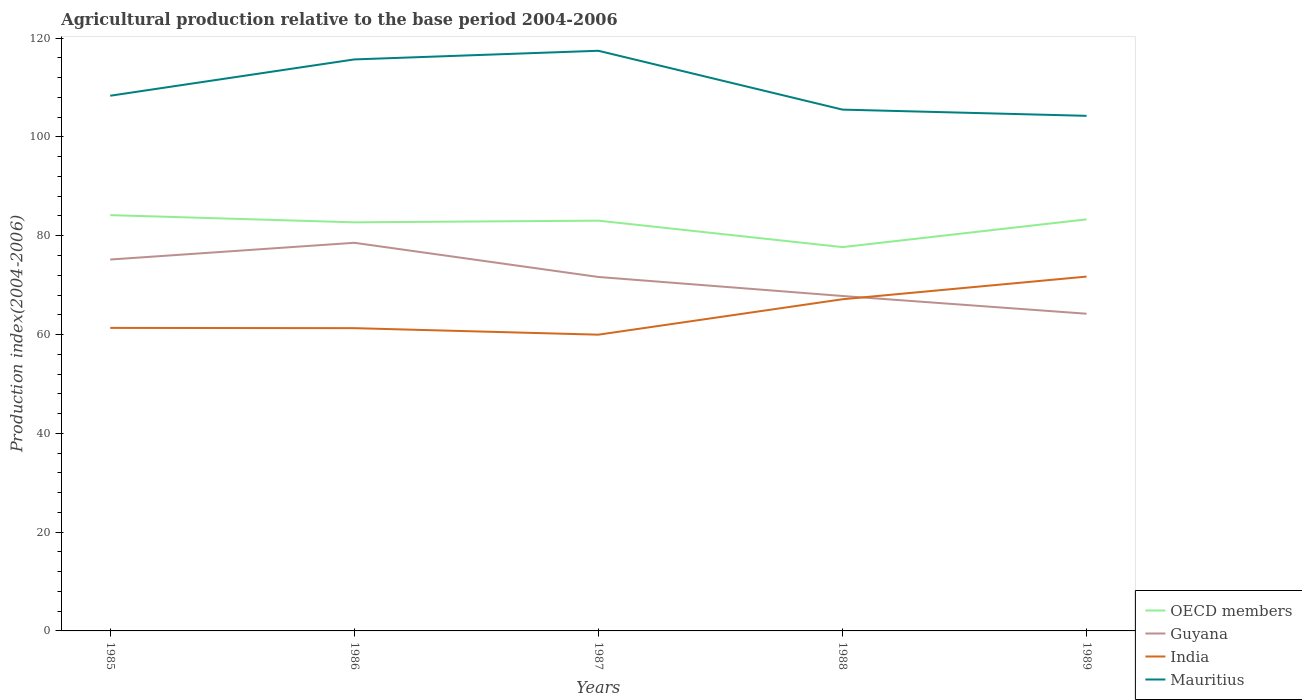How many different coloured lines are there?
Provide a short and direct response. 4. Across all years, what is the maximum agricultural production index in OECD members?
Give a very brief answer. 77.7. What is the total agricultural production index in Mauritius in the graph?
Make the answer very short. 2.81. What is the difference between the highest and the second highest agricultural production index in India?
Provide a succinct answer. 11.76. Are the values on the major ticks of Y-axis written in scientific E-notation?
Offer a terse response. No. Does the graph contain any zero values?
Offer a very short reply. No. Where does the legend appear in the graph?
Offer a terse response. Bottom right. What is the title of the graph?
Provide a short and direct response. Agricultural production relative to the base period 2004-2006. Does "Netherlands" appear as one of the legend labels in the graph?
Provide a short and direct response. No. What is the label or title of the Y-axis?
Provide a succinct answer. Production index(2004-2006). What is the Production index(2004-2006) of OECD members in 1985?
Your response must be concise. 84.17. What is the Production index(2004-2006) in Guyana in 1985?
Make the answer very short. 75.18. What is the Production index(2004-2006) of India in 1985?
Your response must be concise. 61.34. What is the Production index(2004-2006) in Mauritius in 1985?
Keep it short and to the point. 108.34. What is the Production index(2004-2006) in OECD members in 1986?
Give a very brief answer. 82.71. What is the Production index(2004-2006) in Guyana in 1986?
Keep it short and to the point. 78.57. What is the Production index(2004-2006) of India in 1986?
Offer a terse response. 61.29. What is the Production index(2004-2006) in Mauritius in 1986?
Offer a very short reply. 115.69. What is the Production index(2004-2006) in OECD members in 1987?
Your response must be concise. 83.05. What is the Production index(2004-2006) of Guyana in 1987?
Your response must be concise. 71.65. What is the Production index(2004-2006) of India in 1987?
Offer a very short reply. 59.97. What is the Production index(2004-2006) in Mauritius in 1987?
Provide a short and direct response. 117.44. What is the Production index(2004-2006) of OECD members in 1988?
Your answer should be compact. 77.7. What is the Production index(2004-2006) in Guyana in 1988?
Your answer should be compact. 67.8. What is the Production index(2004-2006) in India in 1988?
Make the answer very short. 67.14. What is the Production index(2004-2006) of Mauritius in 1988?
Ensure brevity in your answer.  105.53. What is the Production index(2004-2006) of OECD members in 1989?
Your answer should be compact. 83.31. What is the Production index(2004-2006) of Guyana in 1989?
Ensure brevity in your answer.  64.21. What is the Production index(2004-2006) in India in 1989?
Provide a succinct answer. 71.73. What is the Production index(2004-2006) of Mauritius in 1989?
Offer a terse response. 104.27. Across all years, what is the maximum Production index(2004-2006) of OECD members?
Keep it short and to the point. 84.17. Across all years, what is the maximum Production index(2004-2006) of Guyana?
Provide a short and direct response. 78.57. Across all years, what is the maximum Production index(2004-2006) in India?
Keep it short and to the point. 71.73. Across all years, what is the maximum Production index(2004-2006) in Mauritius?
Your answer should be compact. 117.44. Across all years, what is the minimum Production index(2004-2006) in OECD members?
Make the answer very short. 77.7. Across all years, what is the minimum Production index(2004-2006) of Guyana?
Offer a very short reply. 64.21. Across all years, what is the minimum Production index(2004-2006) of India?
Your response must be concise. 59.97. Across all years, what is the minimum Production index(2004-2006) in Mauritius?
Provide a short and direct response. 104.27. What is the total Production index(2004-2006) in OECD members in the graph?
Keep it short and to the point. 410.94. What is the total Production index(2004-2006) of Guyana in the graph?
Make the answer very short. 357.41. What is the total Production index(2004-2006) of India in the graph?
Give a very brief answer. 321.47. What is the total Production index(2004-2006) in Mauritius in the graph?
Ensure brevity in your answer.  551.27. What is the difference between the Production index(2004-2006) of OECD members in 1985 and that in 1986?
Your response must be concise. 1.46. What is the difference between the Production index(2004-2006) in Guyana in 1985 and that in 1986?
Your answer should be very brief. -3.39. What is the difference between the Production index(2004-2006) of Mauritius in 1985 and that in 1986?
Your response must be concise. -7.35. What is the difference between the Production index(2004-2006) of OECD members in 1985 and that in 1987?
Provide a succinct answer. 1.12. What is the difference between the Production index(2004-2006) of Guyana in 1985 and that in 1987?
Your answer should be compact. 3.53. What is the difference between the Production index(2004-2006) of India in 1985 and that in 1987?
Provide a succinct answer. 1.37. What is the difference between the Production index(2004-2006) in OECD members in 1985 and that in 1988?
Your response must be concise. 6.47. What is the difference between the Production index(2004-2006) of Guyana in 1985 and that in 1988?
Your response must be concise. 7.38. What is the difference between the Production index(2004-2006) of India in 1985 and that in 1988?
Your response must be concise. -5.8. What is the difference between the Production index(2004-2006) of Mauritius in 1985 and that in 1988?
Ensure brevity in your answer.  2.81. What is the difference between the Production index(2004-2006) of OECD members in 1985 and that in 1989?
Make the answer very short. 0.86. What is the difference between the Production index(2004-2006) of Guyana in 1985 and that in 1989?
Your response must be concise. 10.97. What is the difference between the Production index(2004-2006) in India in 1985 and that in 1989?
Provide a succinct answer. -10.39. What is the difference between the Production index(2004-2006) in Mauritius in 1985 and that in 1989?
Your answer should be very brief. 4.07. What is the difference between the Production index(2004-2006) in OECD members in 1986 and that in 1987?
Your answer should be very brief. -0.34. What is the difference between the Production index(2004-2006) of Guyana in 1986 and that in 1987?
Ensure brevity in your answer.  6.92. What is the difference between the Production index(2004-2006) in India in 1986 and that in 1987?
Your answer should be compact. 1.32. What is the difference between the Production index(2004-2006) of Mauritius in 1986 and that in 1987?
Keep it short and to the point. -1.75. What is the difference between the Production index(2004-2006) in OECD members in 1986 and that in 1988?
Ensure brevity in your answer.  5.01. What is the difference between the Production index(2004-2006) in Guyana in 1986 and that in 1988?
Give a very brief answer. 10.77. What is the difference between the Production index(2004-2006) of India in 1986 and that in 1988?
Your answer should be very brief. -5.85. What is the difference between the Production index(2004-2006) of Mauritius in 1986 and that in 1988?
Ensure brevity in your answer.  10.16. What is the difference between the Production index(2004-2006) of OECD members in 1986 and that in 1989?
Your answer should be compact. -0.6. What is the difference between the Production index(2004-2006) of Guyana in 1986 and that in 1989?
Ensure brevity in your answer.  14.36. What is the difference between the Production index(2004-2006) in India in 1986 and that in 1989?
Provide a short and direct response. -10.44. What is the difference between the Production index(2004-2006) in Mauritius in 1986 and that in 1989?
Offer a very short reply. 11.42. What is the difference between the Production index(2004-2006) of OECD members in 1987 and that in 1988?
Make the answer very short. 5.36. What is the difference between the Production index(2004-2006) of Guyana in 1987 and that in 1988?
Provide a short and direct response. 3.85. What is the difference between the Production index(2004-2006) of India in 1987 and that in 1988?
Keep it short and to the point. -7.17. What is the difference between the Production index(2004-2006) of Mauritius in 1987 and that in 1988?
Provide a succinct answer. 11.91. What is the difference between the Production index(2004-2006) in OECD members in 1987 and that in 1989?
Your response must be concise. -0.26. What is the difference between the Production index(2004-2006) of Guyana in 1987 and that in 1989?
Offer a very short reply. 7.44. What is the difference between the Production index(2004-2006) of India in 1987 and that in 1989?
Give a very brief answer. -11.76. What is the difference between the Production index(2004-2006) in Mauritius in 1987 and that in 1989?
Provide a short and direct response. 13.17. What is the difference between the Production index(2004-2006) in OECD members in 1988 and that in 1989?
Ensure brevity in your answer.  -5.62. What is the difference between the Production index(2004-2006) in Guyana in 1988 and that in 1989?
Make the answer very short. 3.59. What is the difference between the Production index(2004-2006) of India in 1988 and that in 1989?
Offer a terse response. -4.59. What is the difference between the Production index(2004-2006) in Mauritius in 1988 and that in 1989?
Offer a very short reply. 1.26. What is the difference between the Production index(2004-2006) in OECD members in 1985 and the Production index(2004-2006) in Guyana in 1986?
Offer a terse response. 5.6. What is the difference between the Production index(2004-2006) of OECD members in 1985 and the Production index(2004-2006) of India in 1986?
Keep it short and to the point. 22.88. What is the difference between the Production index(2004-2006) in OECD members in 1985 and the Production index(2004-2006) in Mauritius in 1986?
Provide a short and direct response. -31.52. What is the difference between the Production index(2004-2006) of Guyana in 1985 and the Production index(2004-2006) of India in 1986?
Provide a short and direct response. 13.89. What is the difference between the Production index(2004-2006) in Guyana in 1985 and the Production index(2004-2006) in Mauritius in 1986?
Your answer should be very brief. -40.51. What is the difference between the Production index(2004-2006) in India in 1985 and the Production index(2004-2006) in Mauritius in 1986?
Ensure brevity in your answer.  -54.35. What is the difference between the Production index(2004-2006) of OECD members in 1985 and the Production index(2004-2006) of Guyana in 1987?
Your answer should be very brief. 12.52. What is the difference between the Production index(2004-2006) of OECD members in 1985 and the Production index(2004-2006) of India in 1987?
Offer a terse response. 24.2. What is the difference between the Production index(2004-2006) in OECD members in 1985 and the Production index(2004-2006) in Mauritius in 1987?
Offer a terse response. -33.27. What is the difference between the Production index(2004-2006) of Guyana in 1985 and the Production index(2004-2006) of India in 1987?
Offer a terse response. 15.21. What is the difference between the Production index(2004-2006) of Guyana in 1985 and the Production index(2004-2006) of Mauritius in 1987?
Your response must be concise. -42.26. What is the difference between the Production index(2004-2006) in India in 1985 and the Production index(2004-2006) in Mauritius in 1987?
Offer a terse response. -56.1. What is the difference between the Production index(2004-2006) of OECD members in 1985 and the Production index(2004-2006) of Guyana in 1988?
Offer a very short reply. 16.37. What is the difference between the Production index(2004-2006) in OECD members in 1985 and the Production index(2004-2006) in India in 1988?
Your answer should be compact. 17.03. What is the difference between the Production index(2004-2006) in OECD members in 1985 and the Production index(2004-2006) in Mauritius in 1988?
Provide a succinct answer. -21.36. What is the difference between the Production index(2004-2006) of Guyana in 1985 and the Production index(2004-2006) of India in 1988?
Provide a short and direct response. 8.04. What is the difference between the Production index(2004-2006) of Guyana in 1985 and the Production index(2004-2006) of Mauritius in 1988?
Your response must be concise. -30.35. What is the difference between the Production index(2004-2006) of India in 1985 and the Production index(2004-2006) of Mauritius in 1988?
Your response must be concise. -44.19. What is the difference between the Production index(2004-2006) in OECD members in 1985 and the Production index(2004-2006) in Guyana in 1989?
Your answer should be compact. 19.96. What is the difference between the Production index(2004-2006) in OECD members in 1985 and the Production index(2004-2006) in India in 1989?
Give a very brief answer. 12.44. What is the difference between the Production index(2004-2006) of OECD members in 1985 and the Production index(2004-2006) of Mauritius in 1989?
Your answer should be very brief. -20.1. What is the difference between the Production index(2004-2006) of Guyana in 1985 and the Production index(2004-2006) of India in 1989?
Provide a short and direct response. 3.45. What is the difference between the Production index(2004-2006) in Guyana in 1985 and the Production index(2004-2006) in Mauritius in 1989?
Give a very brief answer. -29.09. What is the difference between the Production index(2004-2006) in India in 1985 and the Production index(2004-2006) in Mauritius in 1989?
Keep it short and to the point. -42.93. What is the difference between the Production index(2004-2006) in OECD members in 1986 and the Production index(2004-2006) in Guyana in 1987?
Make the answer very short. 11.06. What is the difference between the Production index(2004-2006) of OECD members in 1986 and the Production index(2004-2006) of India in 1987?
Provide a short and direct response. 22.74. What is the difference between the Production index(2004-2006) of OECD members in 1986 and the Production index(2004-2006) of Mauritius in 1987?
Your answer should be very brief. -34.73. What is the difference between the Production index(2004-2006) in Guyana in 1986 and the Production index(2004-2006) in Mauritius in 1987?
Provide a succinct answer. -38.87. What is the difference between the Production index(2004-2006) in India in 1986 and the Production index(2004-2006) in Mauritius in 1987?
Provide a short and direct response. -56.15. What is the difference between the Production index(2004-2006) of OECD members in 1986 and the Production index(2004-2006) of Guyana in 1988?
Offer a terse response. 14.91. What is the difference between the Production index(2004-2006) in OECD members in 1986 and the Production index(2004-2006) in India in 1988?
Ensure brevity in your answer.  15.57. What is the difference between the Production index(2004-2006) in OECD members in 1986 and the Production index(2004-2006) in Mauritius in 1988?
Offer a terse response. -22.82. What is the difference between the Production index(2004-2006) of Guyana in 1986 and the Production index(2004-2006) of India in 1988?
Your response must be concise. 11.43. What is the difference between the Production index(2004-2006) of Guyana in 1986 and the Production index(2004-2006) of Mauritius in 1988?
Ensure brevity in your answer.  -26.96. What is the difference between the Production index(2004-2006) in India in 1986 and the Production index(2004-2006) in Mauritius in 1988?
Give a very brief answer. -44.24. What is the difference between the Production index(2004-2006) of OECD members in 1986 and the Production index(2004-2006) of Guyana in 1989?
Make the answer very short. 18.5. What is the difference between the Production index(2004-2006) of OECD members in 1986 and the Production index(2004-2006) of India in 1989?
Provide a succinct answer. 10.98. What is the difference between the Production index(2004-2006) of OECD members in 1986 and the Production index(2004-2006) of Mauritius in 1989?
Provide a short and direct response. -21.56. What is the difference between the Production index(2004-2006) in Guyana in 1986 and the Production index(2004-2006) in India in 1989?
Your response must be concise. 6.84. What is the difference between the Production index(2004-2006) of Guyana in 1986 and the Production index(2004-2006) of Mauritius in 1989?
Your response must be concise. -25.7. What is the difference between the Production index(2004-2006) of India in 1986 and the Production index(2004-2006) of Mauritius in 1989?
Ensure brevity in your answer.  -42.98. What is the difference between the Production index(2004-2006) in OECD members in 1987 and the Production index(2004-2006) in Guyana in 1988?
Offer a terse response. 15.25. What is the difference between the Production index(2004-2006) in OECD members in 1987 and the Production index(2004-2006) in India in 1988?
Your answer should be compact. 15.91. What is the difference between the Production index(2004-2006) of OECD members in 1987 and the Production index(2004-2006) of Mauritius in 1988?
Provide a short and direct response. -22.48. What is the difference between the Production index(2004-2006) in Guyana in 1987 and the Production index(2004-2006) in India in 1988?
Your response must be concise. 4.51. What is the difference between the Production index(2004-2006) of Guyana in 1987 and the Production index(2004-2006) of Mauritius in 1988?
Offer a very short reply. -33.88. What is the difference between the Production index(2004-2006) in India in 1987 and the Production index(2004-2006) in Mauritius in 1988?
Make the answer very short. -45.56. What is the difference between the Production index(2004-2006) of OECD members in 1987 and the Production index(2004-2006) of Guyana in 1989?
Provide a succinct answer. 18.84. What is the difference between the Production index(2004-2006) in OECD members in 1987 and the Production index(2004-2006) in India in 1989?
Your answer should be compact. 11.32. What is the difference between the Production index(2004-2006) in OECD members in 1987 and the Production index(2004-2006) in Mauritius in 1989?
Your response must be concise. -21.22. What is the difference between the Production index(2004-2006) of Guyana in 1987 and the Production index(2004-2006) of India in 1989?
Provide a short and direct response. -0.08. What is the difference between the Production index(2004-2006) in Guyana in 1987 and the Production index(2004-2006) in Mauritius in 1989?
Your response must be concise. -32.62. What is the difference between the Production index(2004-2006) in India in 1987 and the Production index(2004-2006) in Mauritius in 1989?
Provide a succinct answer. -44.3. What is the difference between the Production index(2004-2006) in OECD members in 1988 and the Production index(2004-2006) in Guyana in 1989?
Offer a terse response. 13.49. What is the difference between the Production index(2004-2006) of OECD members in 1988 and the Production index(2004-2006) of India in 1989?
Offer a very short reply. 5.97. What is the difference between the Production index(2004-2006) of OECD members in 1988 and the Production index(2004-2006) of Mauritius in 1989?
Give a very brief answer. -26.57. What is the difference between the Production index(2004-2006) of Guyana in 1988 and the Production index(2004-2006) of India in 1989?
Provide a succinct answer. -3.93. What is the difference between the Production index(2004-2006) of Guyana in 1988 and the Production index(2004-2006) of Mauritius in 1989?
Ensure brevity in your answer.  -36.47. What is the difference between the Production index(2004-2006) of India in 1988 and the Production index(2004-2006) of Mauritius in 1989?
Offer a terse response. -37.13. What is the average Production index(2004-2006) of OECD members per year?
Your answer should be very brief. 82.19. What is the average Production index(2004-2006) in Guyana per year?
Give a very brief answer. 71.48. What is the average Production index(2004-2006) in India per year?
Your response must be concise. 64.29. What is the average Production index(2004-2006) of Mauritius per year?
Offer a terse response. 110.25. In the year 1985, what is the difference between the Production index(2004-2006) of OECD members and Production index(2004-2006) of Guyana?
Your answer should be compact. 8.99. In the year 1985, what is the difference between the Production index(2004-2006) in OECD members and Production index(2004-2006) in India?
Keep it short and to the point. 22.83. In the year 1985, what is the difference between the Production index(2004-2006) in OECD members and Production index(2004-2006) in Mauritius?
Keep it short and to the point. -24.17. In the year 1985, what is the difference between the Production index(2004-2006) in Guyana and Production index(2004-2006) in India?
Your answer should be compact. 13.84. In the year 1985, what is the difference between the Production index(2004-2006) of Guyana and Production index(2004-2006) of Mauritius?
Your response must be concise. -33.16. In the year 1985, what is the difference between the Production index(2004-2006) of India and Production index(2004-2006) of Mauritius?
Ensure brevity in your answer.  -47. In the year 1986, what is the difference between the Production index(2004-2006) of OECD members and Production index(2004-2006) of Guyana?
Provide a succinct answer. 4.14. In the year 1986, what is the difference between the Production index(2004-2006) of OECD members and Production index(2004-2006) of India?
Your answer should be compact. 21.42. In the year 1986, what is the difference between the Production index(2004-2006) in OECD members and Production index(2004-2006) in Mauritius?
Give a very brief answer. -32.98. In the year 1986, what is the difference between the Production index(2004-2006) in Guyana and Production index(2004-2006) in India?
Offer a very short reply. 17.28. In the year 1986, what is the difference between the Production index(2004-2006) in Guyana and Production index(2004-2006) in Mauritius?
Your answer should be compact. -37.12. In the year 1986, what is the difference between the Production index(2004-2006) in India and Production index(2004-2006) in Mauritius?
Offer a very short reply. -54.4. In the year 1987, what is the difference between the Production index(2004-2006) in OECD members and Production index(2004-2006) in Guyana?
Your answer should be compact. 11.4. In the year 1987, what is the difference between the Production index(2004-2006) in OECD members and Production index(2004-2006) in India?
Make the answer very short. 23.08. In the year 1987, what is the difference between the Production index(2004-2006) in OECD members and Production index(2004-2006) in Mauritius?
Offer a very short reply. -34.39. In the year 1987, what is the difference between the Production index(2004-2006) in Guyana and Production index(2004-2006) in India?
Keep it short and to the point. 11.68. In the year 1987, what is the difference between the Production index(2004-2006) in Guyana and Production index(2004-2006) in Mauritius?
Provide a succinct answer. -45.79. In the year 1987, what is the difference between the Production index(2004-2006) in India and Production index(2004-2006) in Mauritius?
Your response must be concise. -57.47. In the year 1988, what is the difference between the Production index(2004-2006) of OECD members and Production index(2004-2006) of Guyana?
Provide a succinct answer. 9.9. In the year 1988, what is the difference between the Production index(2004-2006) of OECD members and Production index(2004-2006) of India?
Keep it short and to the point. 10.56. In the year 1988, what is the difference between the Production index(2004-2006) of OECD members and Production index(2004-2006) of Mauritius?
Your answer should be very brief. -27.83. In the year 1988, what is the difference between the Production index(2004-2006) in Guyana and Production index(2004-2006) in India?
Give a very brief answer. 0.66. In the year 1988, what is the difference between the Production index(2004-2006) in Guyana and Production index(2004-2006) in Mauritius?
Keep it short and to the point. -37.73. In the year 1988, what is the difference between the Production index(2004-2006) in India and Production index(2004-2006) in Mauritius?
Keep it short and to the point. -38.39. In the year 1989, what is the difference between the Production index(2004-2006) of OECD members and Production index(2004-2006) of Guyana?
Offer a very short reply. 19.1. In the year 1989, what is the difference between the Production index(2004-2006) of OECD members and Production index(2004-2006) of India?
Provide a short and direct response. 11.58. In the year 1989, what is the difference between the Production index(2004-2006) in OECD members and Production index(2004-2006) in Mauritius?
Keep it short and to the point. -20.96. In the year 1989, what is the difference between the Production index(2004-2006) of Guyana and Production index(2004-2006) of India?
Keep it short and to the point. -7.52. In the year 1989, what is the difference between the Production index(2004-2006) of Guyana and Production index(2004-2006) of Mauritius?
Keep it short and to the point. -40.06. In the year 1989, what is the difference between the Production index(2004-2006) of India and Production index(2004-2006) of Mauritius?
Offer a very short reply. -32.54. What is the ratio of the Production index(2004-2006) in OECD members in 1985 to that in 1986?
Provide a succinct answer. 1.02. What is the ratio of the Production index(2004-2006) of Guyana in 1985 to that in 1986?
Make the answer very short. 0.96. What is the ratio of the Production index(2004-2006) in India in 1985 to that in 1986?
Keep it short and to the point. 1. What is the ratio of the Production index(2004-2006) of Mauritius in 1985 to that in 1986?
Offer a terse response. 0.94. What is the ratio of the Production index(2004-2006) of OECD members in 1985 to that in 1987?
Provide a short and direct response. 1.01. What is the ratio of the Production index(2004-2006) in Guyana in 1985 to that in 1987?
Make the answer very short. 1.05. What is the ratio of the Production index(2004-2006) of India in 1985 to that in 1987?
Offer a terse response. 1.02. What is the ratio of the Production index(2004-2006) of Mauritius in 1985 to that in 1987?
Provide a short and direct response. 0.92. What is the ratio of the Production index(2004-2006) in Guyana in 1985 to that in 1988?
Provide a short and direct response. 1.11. What is the ratio of the Production index(2004-2006) of India in 1985 to that in 1988?
Provide a succinct answer. 0.91. What is the ratio of the Production index(2004-2006) of Mauritius in 1985 to that in 1988?
Your answer should be very brief. 1.03. What is the ratio of the Production index(2004-2006) in OECD members in 1985 to that in 1989?
Offer a terse response. 1.01. What is the ratio of the Production index(2004-2006) of Guyana in 1985 to that in 1989?
Your answer should be compact. 1.17. What is the ratio of the Production index(2004-2006) of India in 1985 to that in 1989?
Offer a terse response. 0.86. What is the ratio of the Production index(2004-2006) of Mauritius in 1985 to that in 1989?
Your answer should be very brief. 1.04. What is the ratio of the Production index(2004-2006) of Guyana in 1986 to that in 1987?
Offer a very short reply. 1.1. What is the ratio of the Production index(2004-2006) in Mauritius in 1986 to that in 1987?
Keep it short and to the point. 0.99. What is the ratio of the Production index(2004-2006) in OECD members in 1986 to that in 1988?
Make the answer very short. 1.06. What is the ratio of the Production index(2004-2006) in Guyana in 1986 to that in 1988?
Ensure brevity in your answer.  1.16. What is the ratio of the Production index(2004-2006) of India in 1986 to that in 1988?
Keep it short and to the point. 0.91. What is the ratio of the Production index(2004-2006) of Mauritius in 1986 to that in 1988?
Offer a terse response. 1.1. What is the ratio of the Production index(2004-2006) in Guyana in 1986 to that in 1989?
Give a very brief answer. 1.22. What is the ratio of the Production index(2004-2006) in India in 1986 to that in 1989?
Keep it short and to the point. 0.85. What is the ratio of the Production index(2004-2006) of Mauritius in 1986 to that in 1989?
Offer a very short reply. 1.11. What is the ratio of the Production index(2004-2006) in OECD members in 1987 to that in 1988?
Keep it short and to the point. 1.07. What is the ratio of the Production index(2004-2006) in Guyana in 1987 to that in 1988?
Make the answer very short. 1.06. What is the ratio of the Production index(2004-2006) of India in 1987 to that in 1988?
Make the answer very short. 0.89. What is the ratio of the Production index(2004-2006) in Mauritius in 1987 to that in 1988?
Provide a short and direct response. 1.11. What is the ratio of the Production index(2004-2006) in OECD members in 1987 to that in 1989?
Ensure brevity in your answer.  1. What is the ratio of the Production index(2004-2006) in Guyana in 1987 to that in 1989?
Your response must be concise. 1.12. What is the ratio of the Production index(2004-2006) of India in 1987 to that in 1989?
Your response must be concise. 0.84. What is the ratio of the Production index(2004-2006) in Mauritius in 1987 to that in 1989?
Offer a very short reply. 1.13. What is the ratio of the Production index(2004-2006) of OECD members in 1988 to that in 1989?
Your answer should be compact. 0.93. What is the ratio of the Production index(2004-2006) in Guyana in 1988 to that in 1989?
Provide a succinct answer. 1.06. What is the ratio of the Production index(2004-2006) in India in 1988 to that in 1989?
Make the answer very short. 0.94. What is the ratio of the Production index(2004-2006) in Mauritius in 1988 to that in 1989?
Offer a very short reply. 1.01. What is the difference between the highest and the second highest Production index(2004-2006) of OECD members?
Keep it short and to the point. 0.86. What is the difference between the highest and the second highest Production index(2004-2006) of Guyana?
Ensure brevity in your answer.  3.39. What is the difference between the highest and the second highest Production index(2004-2006) of India?
Provide a succinct answer. 4.59. What is the difference between the highest and the second highest Production index(2004-2006) of Mauritius?
Give a very brief answer. 1.75. What is the difference between the highest and the lowest Production index(2004-2006) of OECD members?
Give a very brief answer. 6.47. What is the difference between the highest and the lowest Production index(2004-2006) of Guyana?
Provide a succinct answer. 14.36. What is the difference between the highest and the lowest Production index(2004-2006) of India?
Ensure brevity in your answer.  11.76. What is the difference between the highest and the lowest Production index(2004-2006) in Mauritius?
Provide a short and direct response. 13.17. 